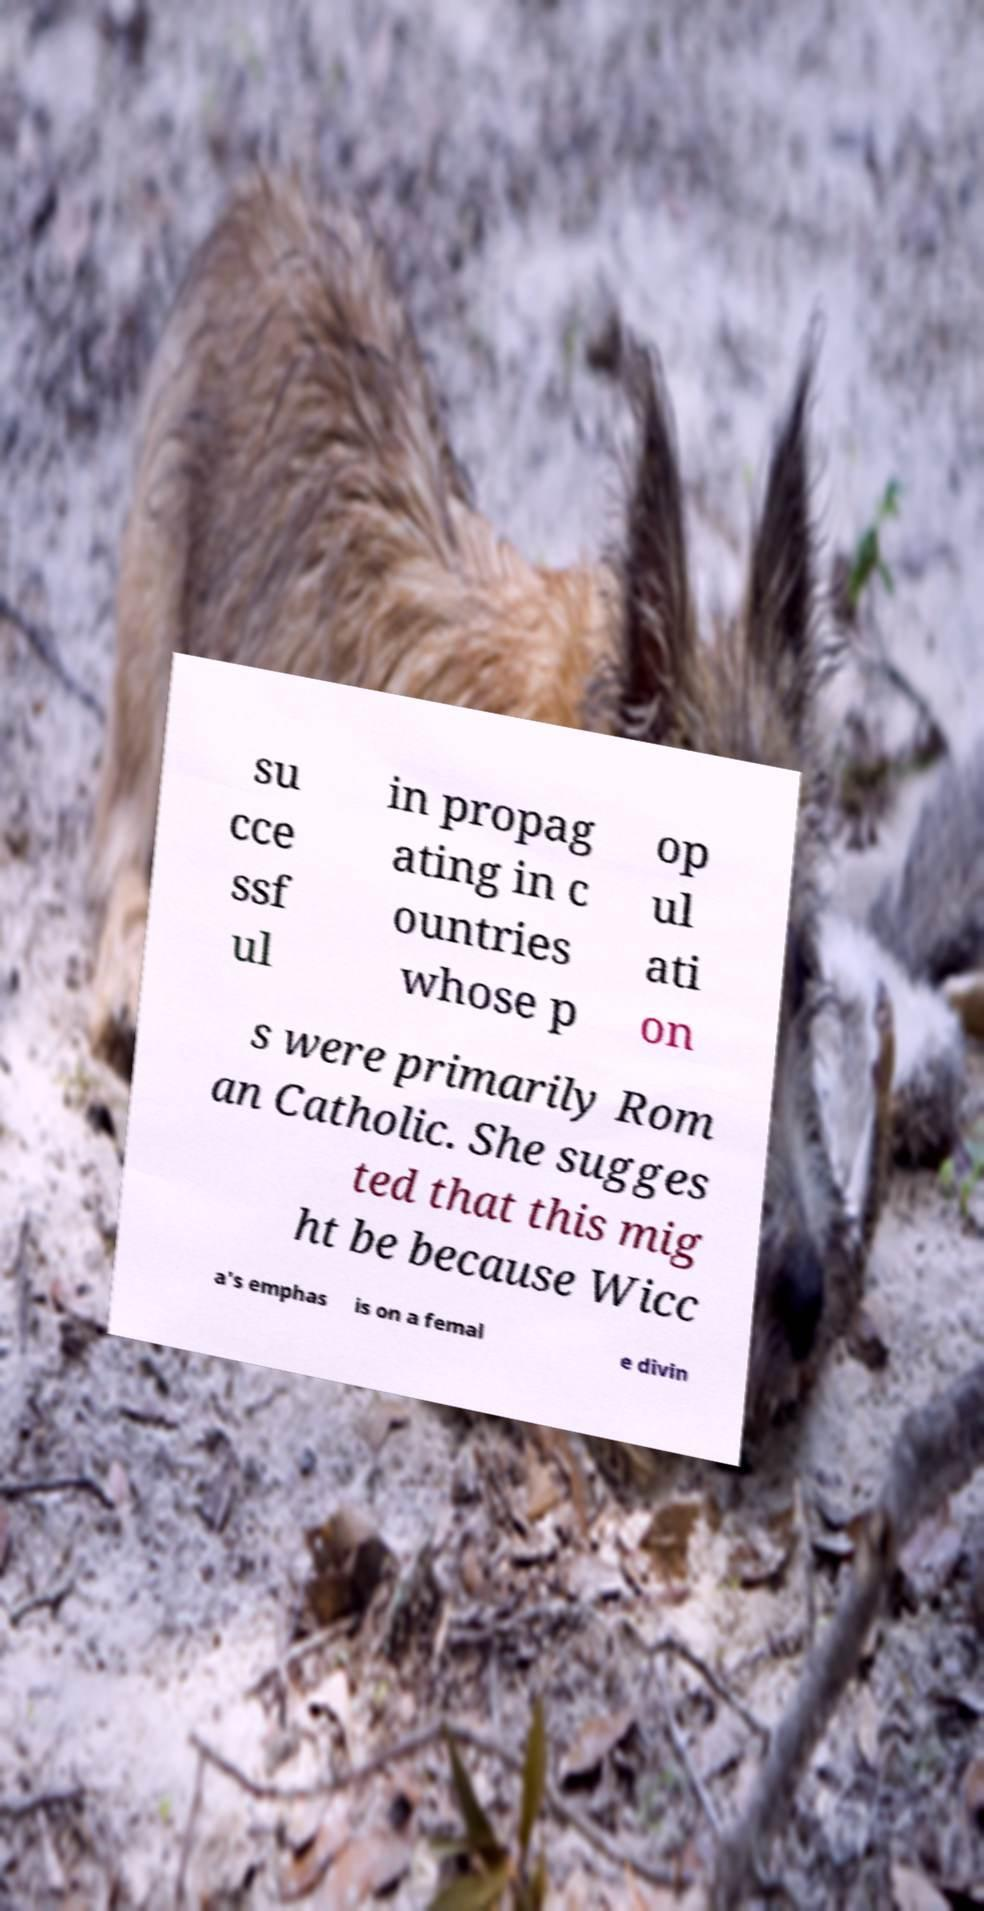Can you accurately transcribe the text from the provided image for me? su cce ssf ul in propag ating in c ountries whose p op ul ati on s were primarily Rom an Catholic. She sugges ted that this mig ht be because Wicc a's emphas is on a femal e divin 